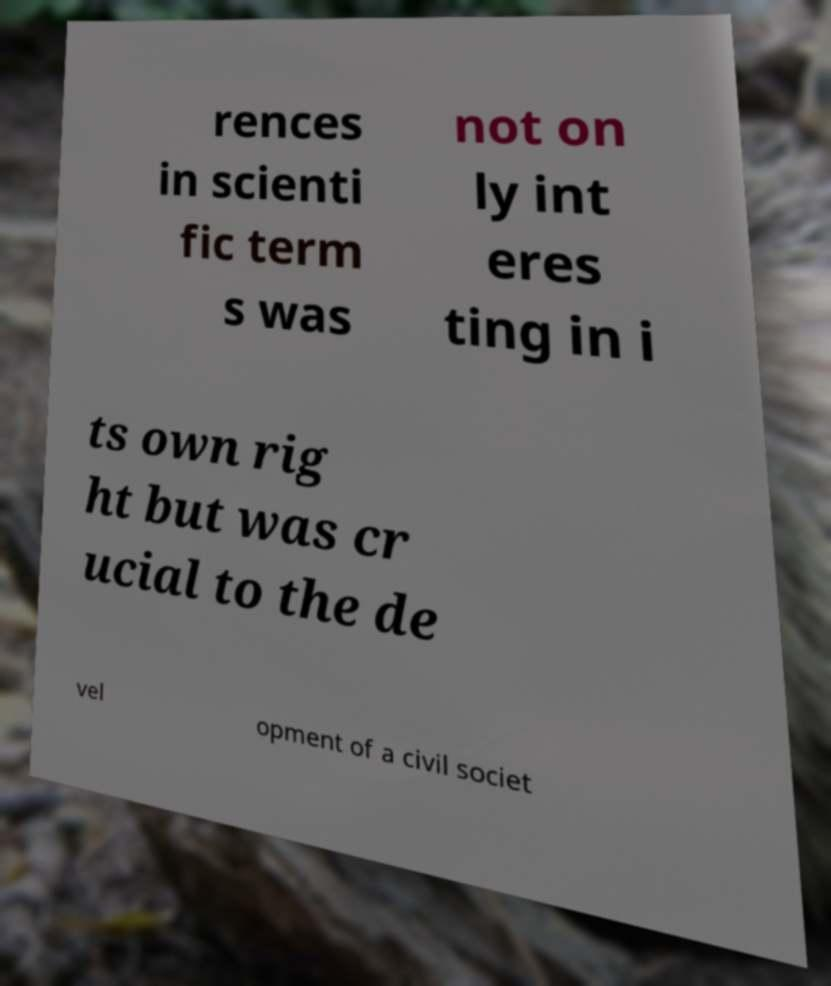I need the written content from this picture converted into text. Can you do that? rences in scienti fic term s was not on ly int eres ting in i ts own rig ht but was cr ucial to the de vel opment of a civil societ 